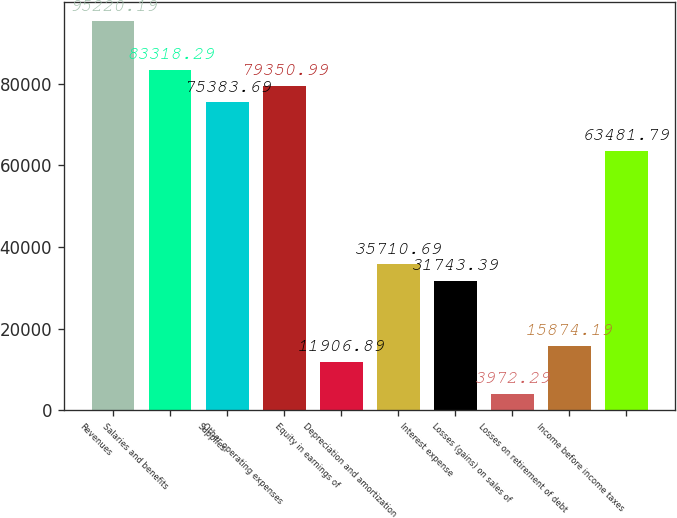Convert chart. <chart><loc_0><loc_0><loc_500><loc_500><bar_chart><fcel>Revenues<fcel>Salaries and benefits<fcel>Supplies<fcel>Other operating expenses<fcel>Equity in earnings of<fcel>Depreciation and amortization<fcel>Interest expense<fcel>Losses (gains) on sales of<fcel>Losses on retirement of debt<fcel>Income before income taxes<nl><fcel>95220.2<fcel>83318.3<fcel>75383.7<fcel>79351<fcel>11906.9<fcel>35710.7<fcel>31743.4<fcel>3972.29<fcel>15874.2<fcel>63481.8<nl></chart> 